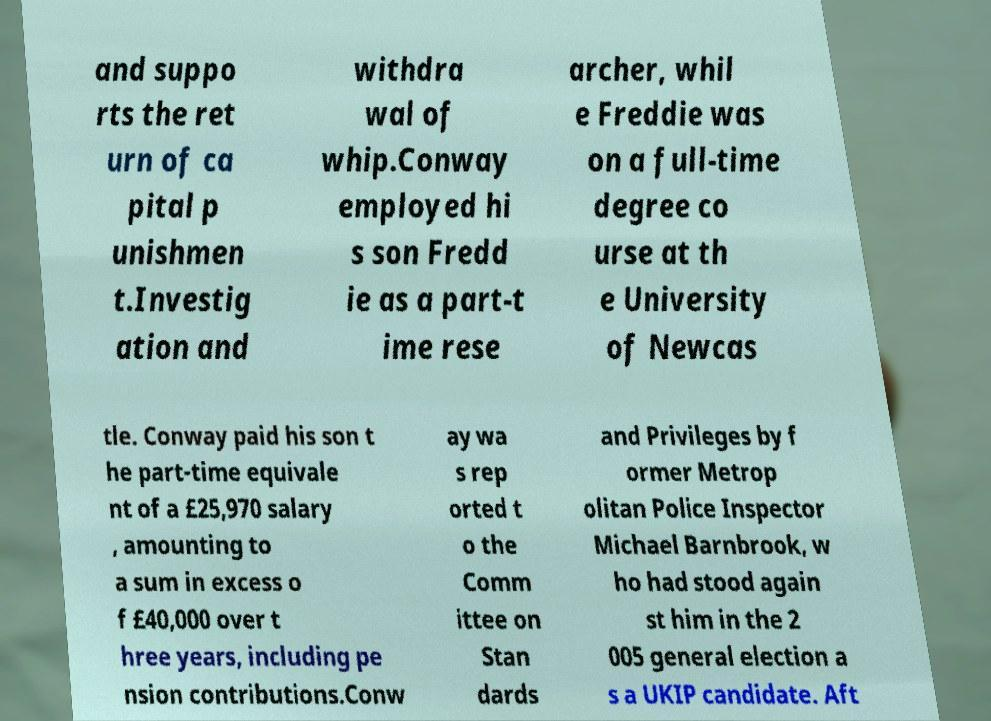Can you accurately transcribe the text from the provided image for me? and suppo rts the ret urn of ca pital p unishmen t.Investig ation and withdra wal of whip.Conway employed hi s son Fredd ie as a part-t ime rese archer, whil e Freddie was on a full-time degree co urse at th e University of Newcas tle. Conway paid his son t he part-time equivale nt of a £25,970 salary , amounting to a sum in excess o f £40,000 over t hree years, including pe nsion contributions.Conw ay wa s rep orted t o the Comm ittee on Stan dards and Privileges by f ormer Metrop olitan Police Inspector Michael Barnbrook, w ho had stood again st him in the 2 005 general election a s a UKIP candidate. Aft 